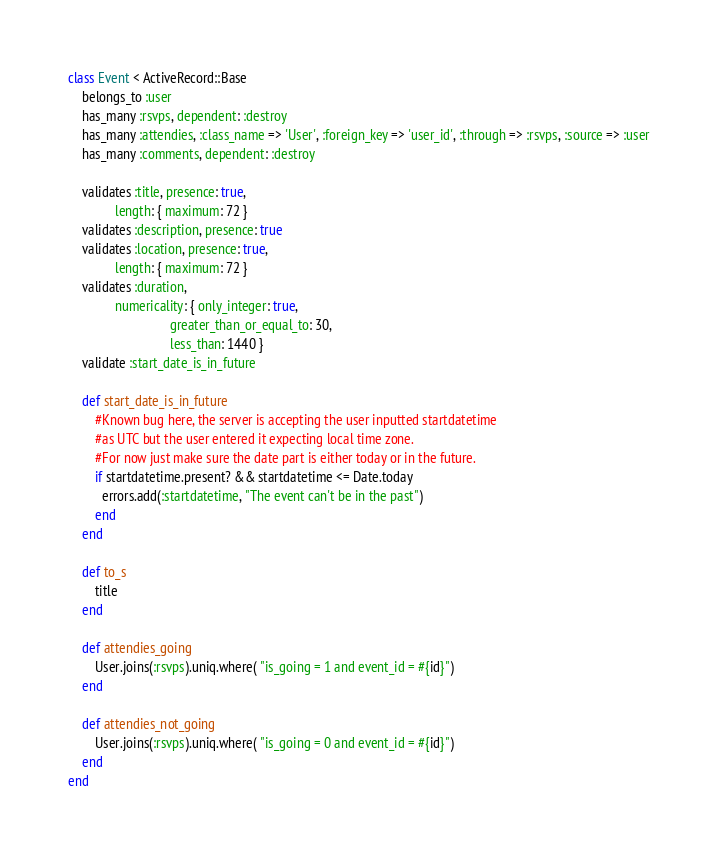<code> <loc_0><loc_0><loc_500><loc_500><_Ruby_>class Event < ActiveRecord::Base
	belongs_to :user
	has_many :rsvps, dependent: :destroy
	has_many :attendies, :class_name => 'User', :foreign_key => 'user_id', :through => :rsvps, :source => :user
	has_many :comments, dependent: :destroy
	
	validates :title, presence: true,
	          length: { maximum: 72 }
	validates :description, presence: true
	validates :location, presence: true,
	          length: { maximum: 72 }
	validates :duration, 
			  numericality: { only_integer: true, 
			  	              greater_than_or_equal_to: 30,
			  				  less_than: 1440 }
	validate :start_date_is_in_future

	def start_date_is_in_future
		#Known bug here, the server is accepting the user inputted startdatetime 
		#as UTC but the user entered it expecting local time zone.
		#For now just make sure the date part is either today or in the future.
		if startdatetime.present? && startdatetime <= Date.today
	      errors.add(:startdatetime, "The event can't be in the past")
	    end
	end

	def to_s
		title
	end

	def attendies_going
		User.joins(:rsvps).uniq.where( "is_going = 1 and event_id = #{id}")
	end

	def attendies_not_going
		User.joins(:rsvps).uniq.where( "is_going = 0 and event_id = #{id}")
	end
end
</code> 